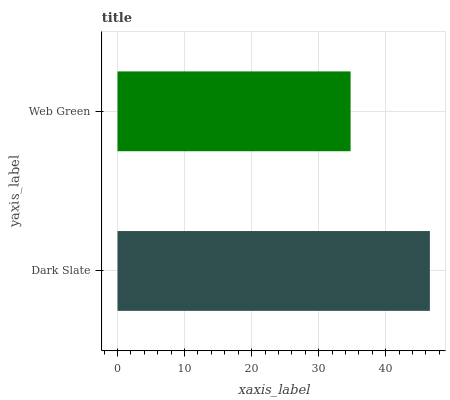Is Web Green the minimum?
Answer yes or no. Yes. Is Dark Slate the maximum?
Answer yes or no. Yes. Is Web Green the maximum?
Answer yes or no. No. Is Dark Slate greater than Web Green?
Answer yes or no. Yes. Is Web Green less than Dark Slate?
Answer yes or no. Yes. Is Web Green greater than Dark Slate?
Answer yes or no. No. Is Dark Slate less than Web Green?
Answer yes or no. No. Is Dark Slate the high median?
Answer yes or no. Yes. Is Web Green the low median?
Answer yes or no. Yes. Is Web Green the high median?
Answer yes or no. No. Is Dark Slate the low median?
Answer yes or no. No. 